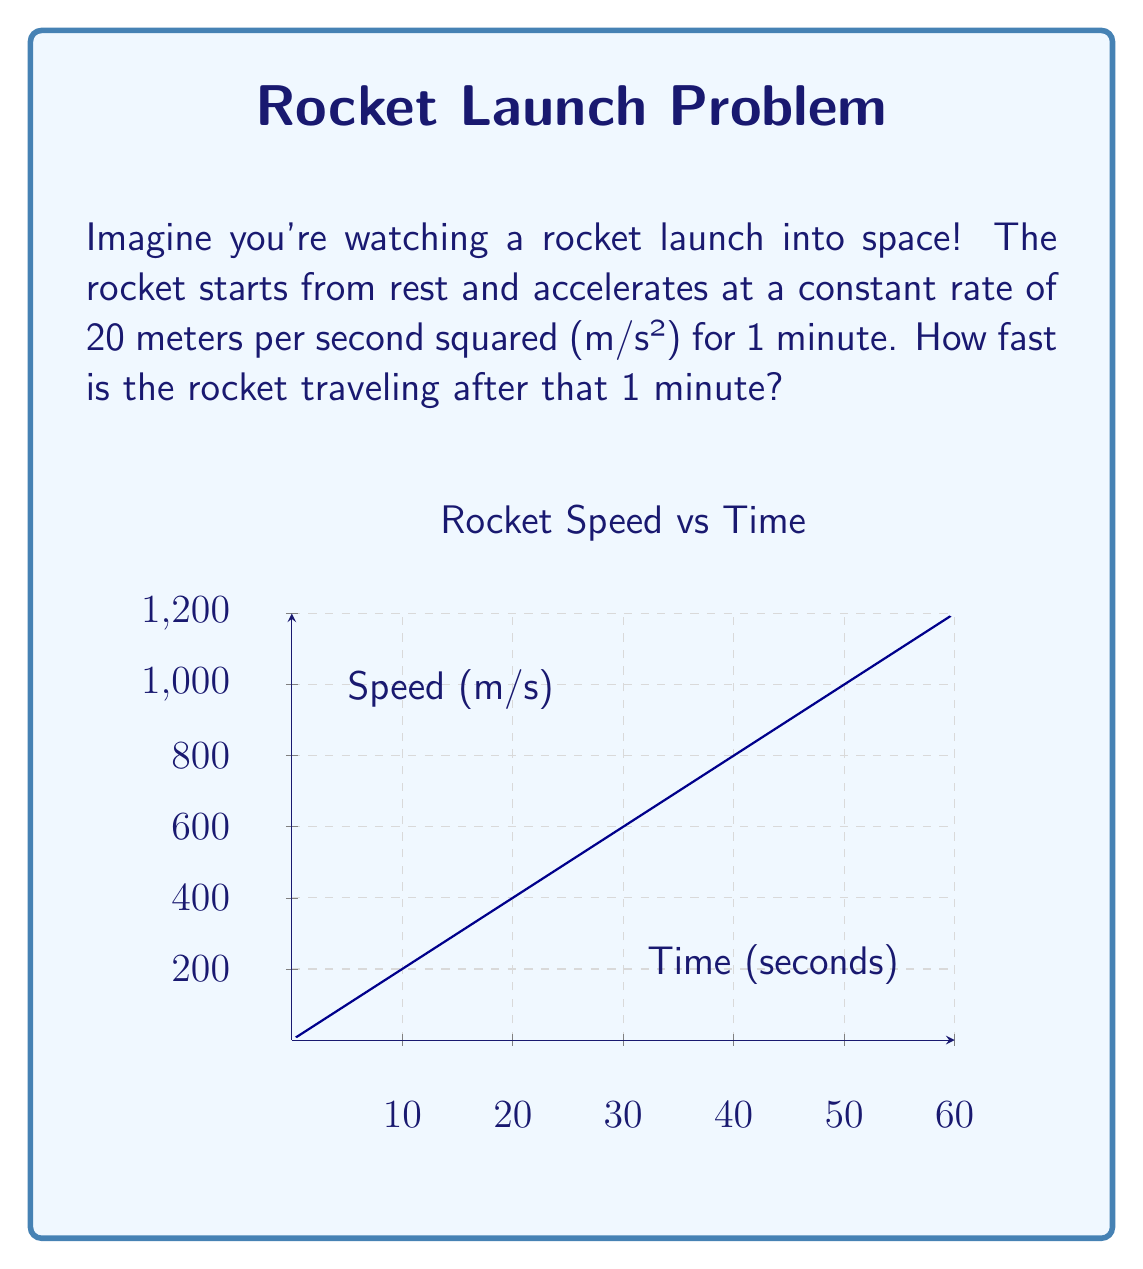Can you solve this math problem? Let's break this down step-by-step:

1) First, we need to understand what acceleration means. Acceleration is how quickly something's speed changes. In this case, the rocket's speed increases by 20 meters per second, every second.

2) We're told that this happens for 1 minute. But our acceleration is given in seconds, so we need to convert 1 minute to seconds:
   1 minute = 60 seconds

3) Now, we can use the formula for speed when we have constant acceleration:
   $v = v_0 + at$
   Where:
   $v$ is the final speed
   $v_0$ is the initial speed (which is 0 in this case, as the rocket starts from rest)
   $a$ is the acceleration (20 m/s²)
   $t$ is the time (60 seconds)

4) Let's plug these values into our formula:
   $v = 0 + 20 \times 60$

5) Now we can solve this:
   $v = 20 \times 60 = 1200$

So, after 1 minute, the rocket is traveling at 1200 meters per second.
Answer: 1200 m/s 